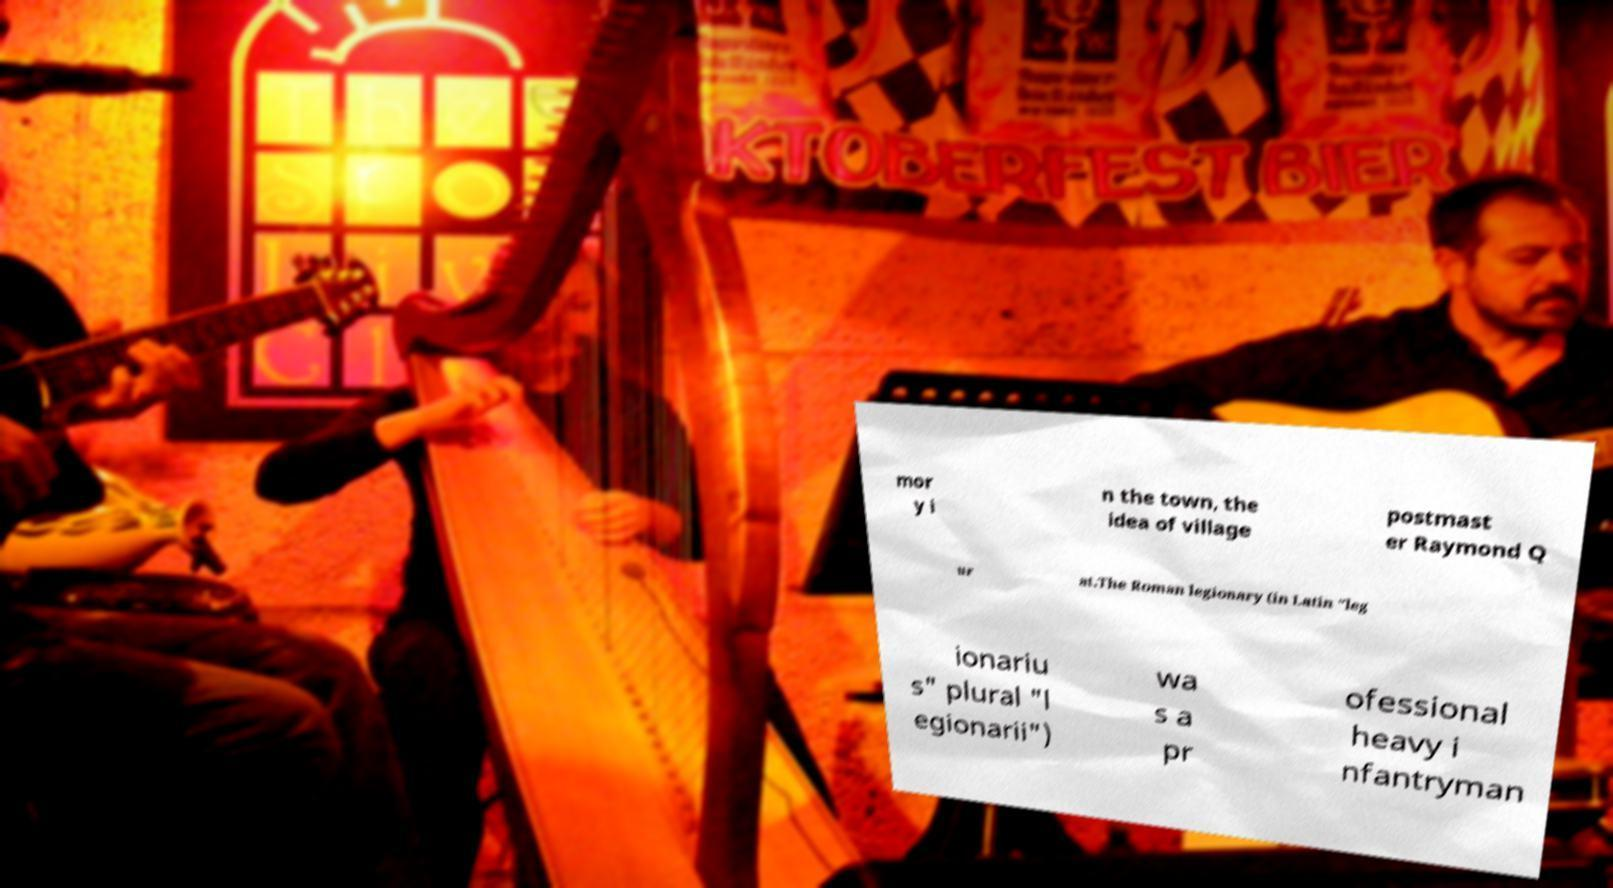Can you read and provide the text displayed in the image?This photo seems to have some interesting text. Can you extract and type it out for me? mor y i n the town, the idea of village postmast er Raymond Q ur at.The Roman legionary (in Latin "leg ionariu s" plural "l egionarii") wa s a pr ofessional heavy i nfantryman 